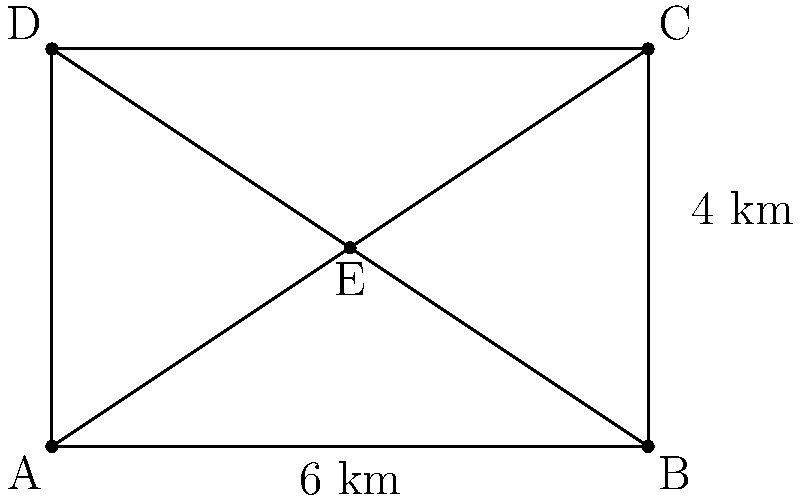Representative McBride's campaign team is planning door-to-door canvassing routes. They have a rectangular area of 6 km by 4 km to cover, as shown in the diagram. To maximize efficiency, they want to compare the coverage areas of two strategies:

1. Dividing the area into four triangular sections by having canvassers start from the center point E and move towards the corners.
2. Dividing the area into two rectangular sections by splitting it down the middle vertically.

Which strategy covers a larger area, and by how much? Round your answer to two decimal places. Let's approach this step-by-step:

1. Calculate the area of one triangular section:
   Base = 3 km, Height = 2 km
   Area of triangle = $\frac{1}{2} \times base \times height = \frac{1}{2} \times 3 \times 2 = 3$ km²

2. Total area covered by four triangular sections:
   $4 \times 3 = 12$ km²

3. Calculate the area of one rectangular section:
   Length = 6 km, Width = 2 km
   Area of rectangle = $length \times width = 6 \times 2 = 12$ km²

4. Total area covered by two rectangular sections:
   $2 \times 12 = 24$ km²

5. Compare the two strategies:
   Rectangular strategy covers: 24 km²
   Triangular strategy covers: 12 km²
   Difference: $24 - 12 = 12$ km²

6. Calculate the percentage difference:
   $\frac{12}{12} \times 100 = 100\%$

Therefore, the rectangular strategy covers 12 km² more, which is 100% larger than the triangular strategy.
Answer: Rectangular strategy; 12.00 km² (100.00%) larger 